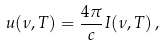<formula> <loc_0><loc_0><loc_500><loc_500>u ( \nu , T ) = \frac { 4 \pi } { c } I ( \nu , T ) \, ,</formula> 